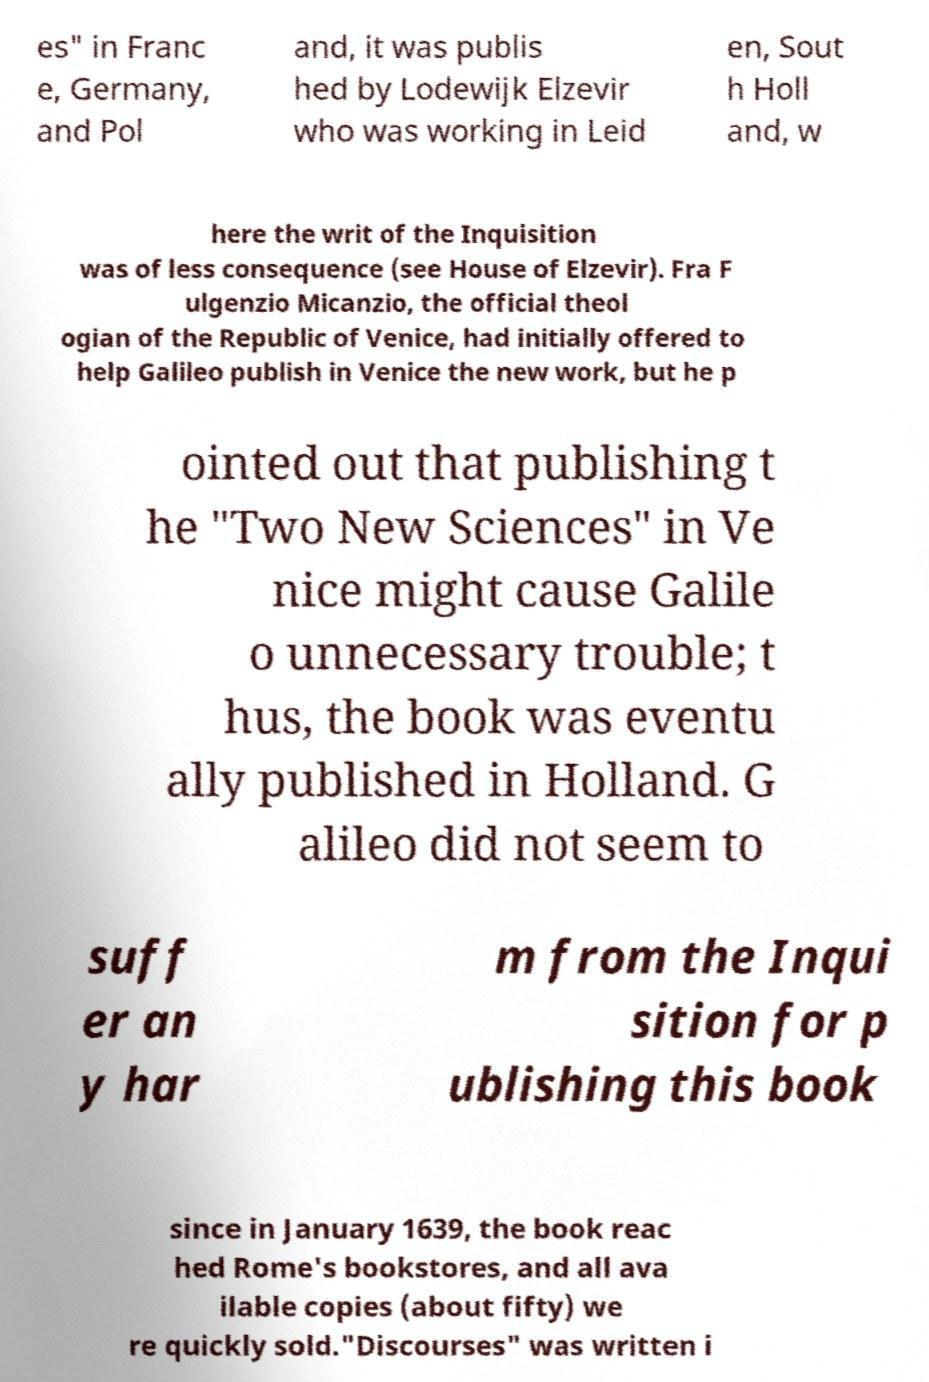For documentation purposes, I need the text within this image transcribed. Could you provide that? es" in Franc e, Germany, and Pol and, it was publis hed by Lodewijk Elzevir who was working in Leid en, Sout h Holl and, w here the writ of the Inquisition was of less consequence (see House of Elzevir). Fra F ulgenzio Micanzio, the official theol ogian of the Republic of Venice, had initially offered to help Galileo publish in Venice the new work, but he p ointed out that publishing t he "Two New Sciences" in Ve nice might cause Galile o unnecessary trouble; t hus, the book was eventu ally published in Holland. G alileo did not seem to suff er an y har m from the Inqui sition for p ublishing this book since in January 1639, the book reac hed Rome's bookstores, and all ava ilable copies (about fifty) we re quickly sold."Discourses" was written i 